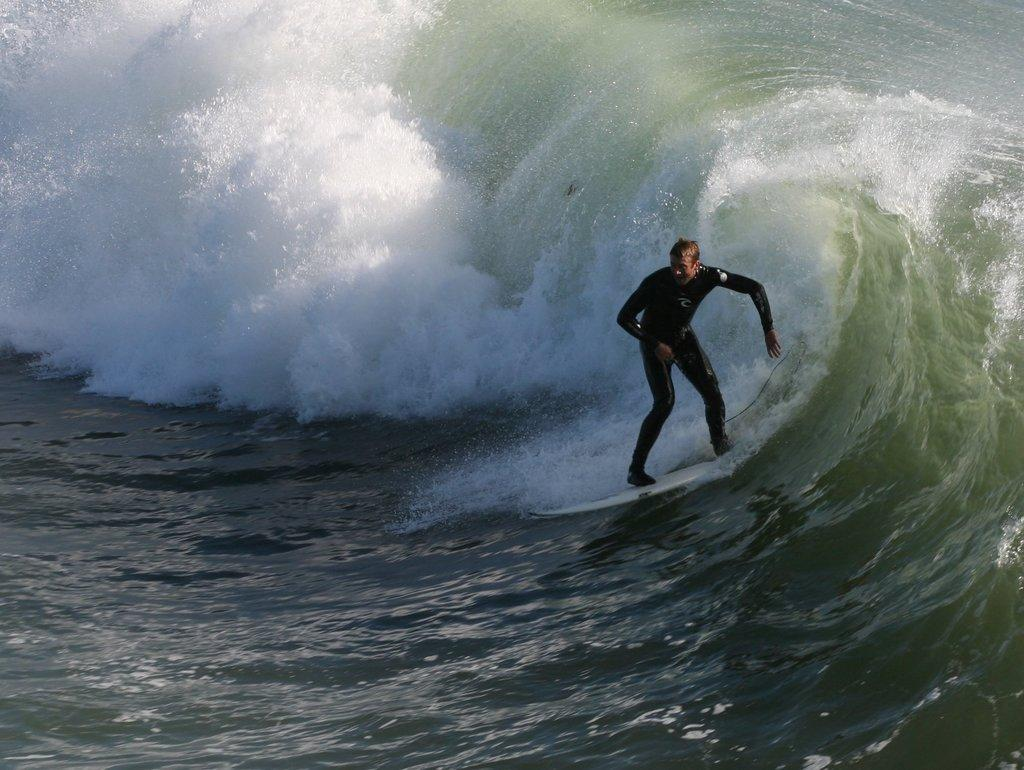What is the main subject of the image? There is a man in the image. What is the man doing in the image? The man is surfing on a surfboard. Where is the surfboard located in the image? The surfboard is on the water. What color is the man's eye in the image? There is no information about the man's eye color in the image. What are the man's hobbies outside of surfing? There is no information about the man's hobbies outside of surfing in the image. 